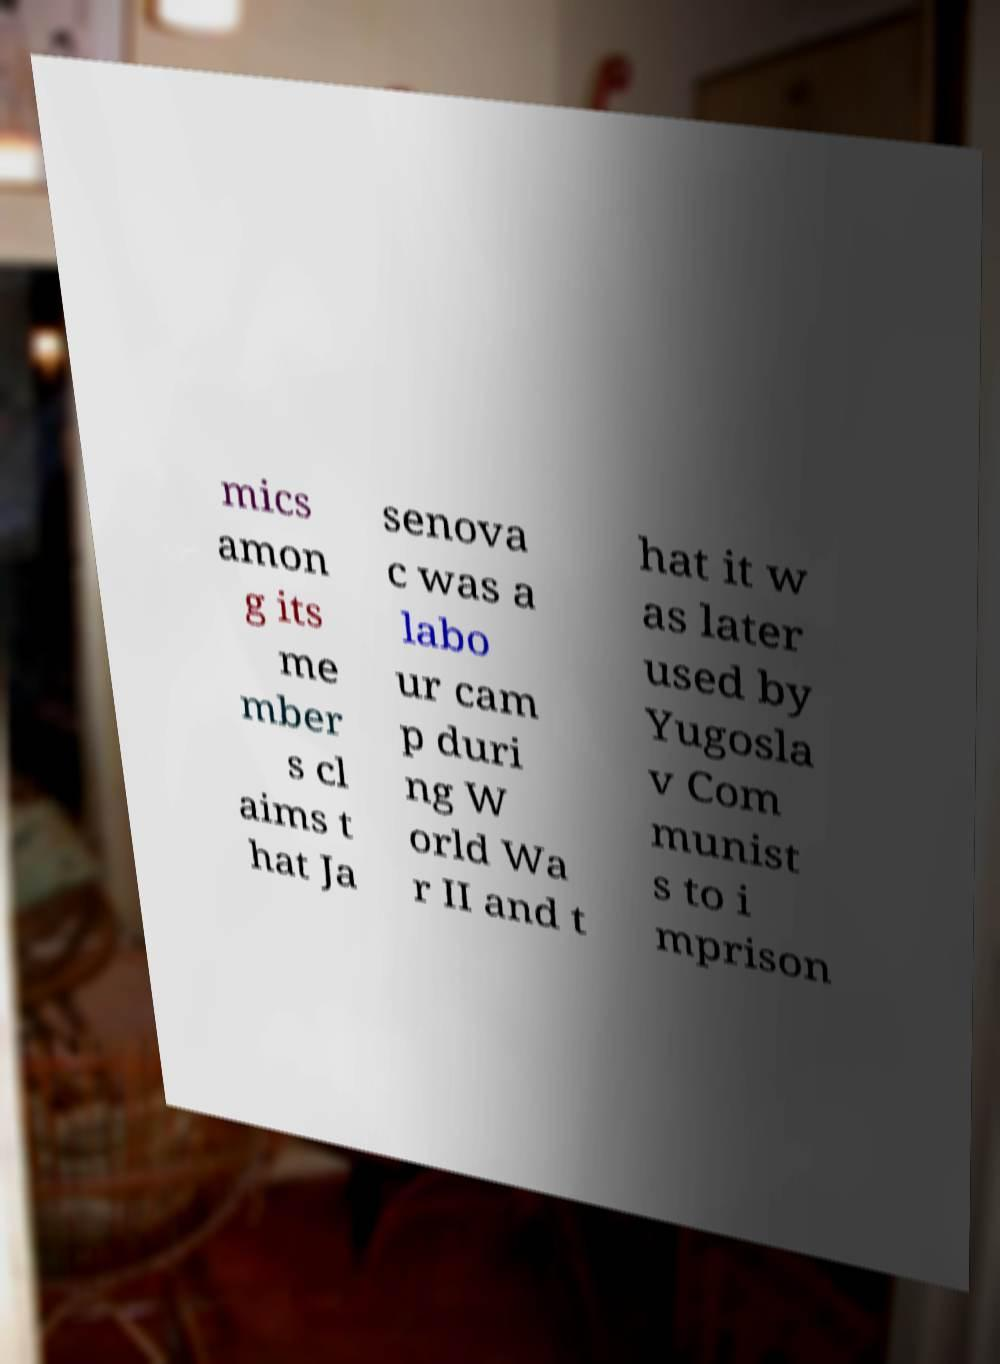Could you assist in decoding the text presented in this image and type it out clearly? mics amon g its me mber s cl aims t hat Ja senova c was a labo ur cam p duri ng W orld Wa r II and t hat it w as later used by Yugosla v Com munist s to i mprison 